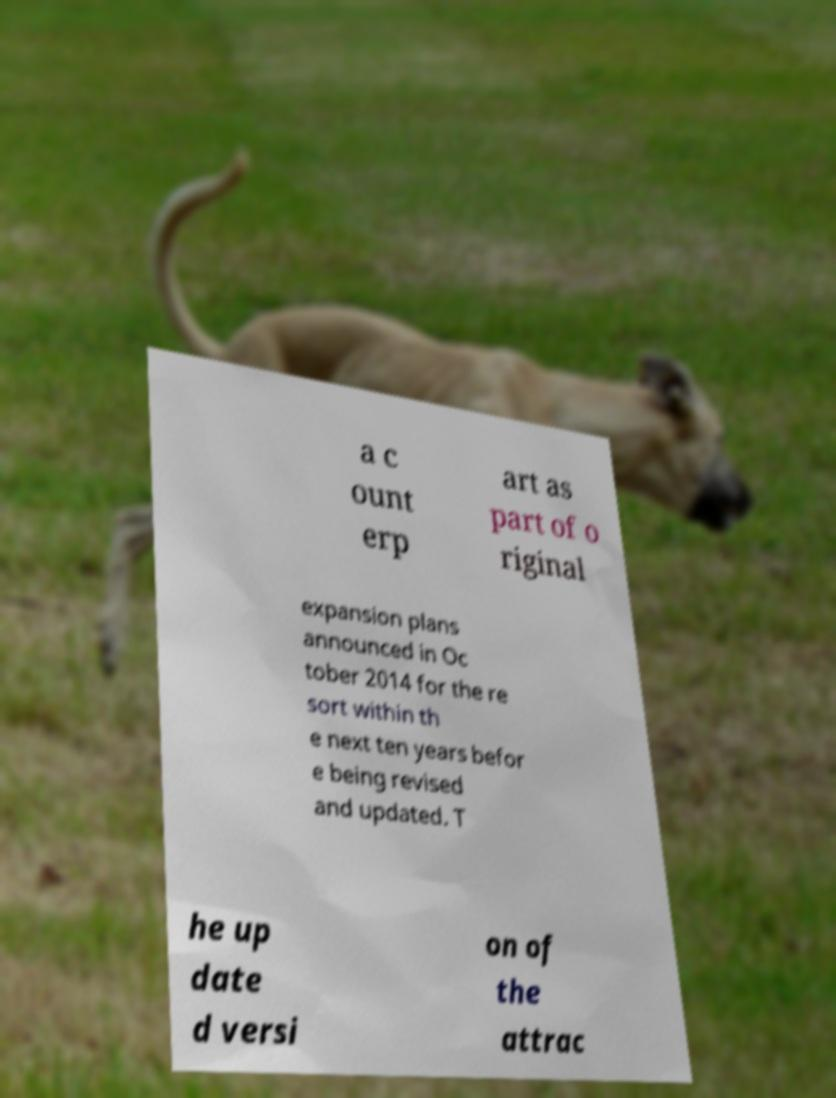Please identify and transcribe the text found in this image. a c ount erp art as part of o riginal expansion plans announced in Oc tober 2014 for the re sort within th e next ten years befor e being revised and updated. T he up date d versi on of the attrac 